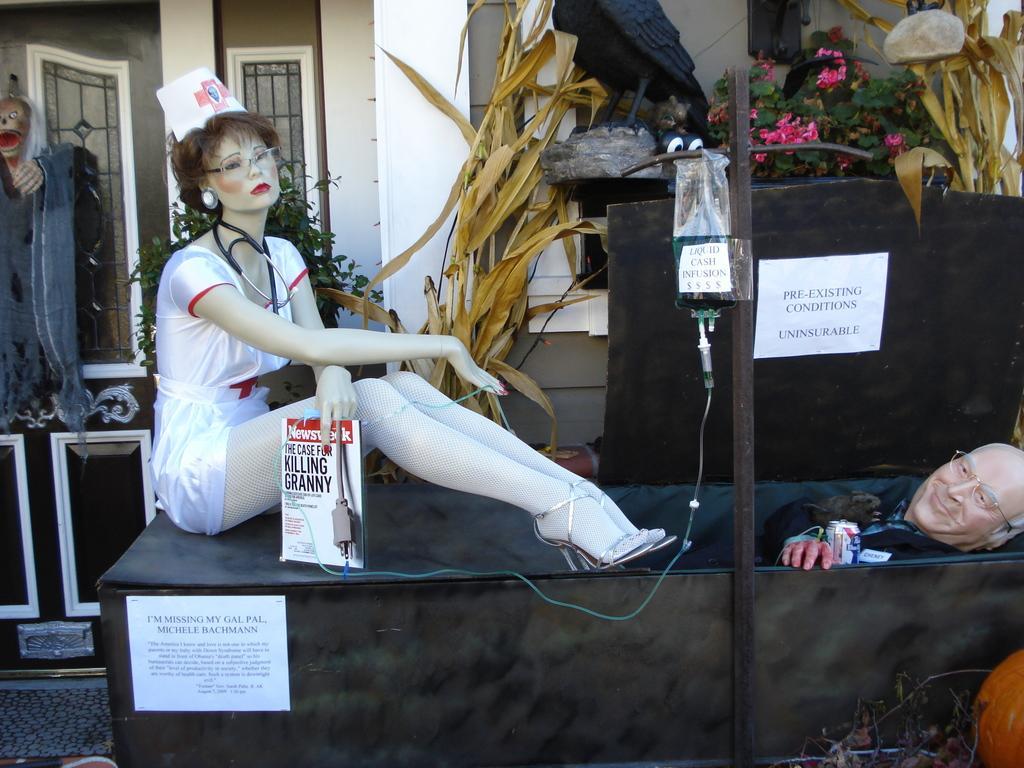Can you describe this image briefly? In this image I can see two mannequins, in front I can see a white color dress. Background I can see a board in black color, few flowers in pink color, plants in green color and the wall is in white color. 